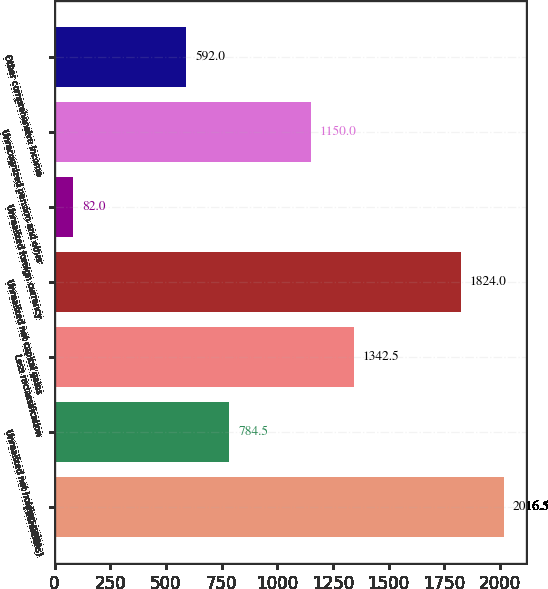Convert chart to OTSL. <chart><loc_0><loc_0><loc_500><loc_500><bar_chart><fcel>( in millions)<fcel>Unrealized net holding gains<fcel>Less reclassification<fcel>Unrealized net capital gains<fcel>Unrealized foreign currency<fcel>Unrecognized pension and other<fcel>Other comprehensive income<nl><fcel>2016.5<fcel>784.5<fcel>1342.5<fcel>1824<fcel>82<fcel>1150<fcel>592<nl></chart> 